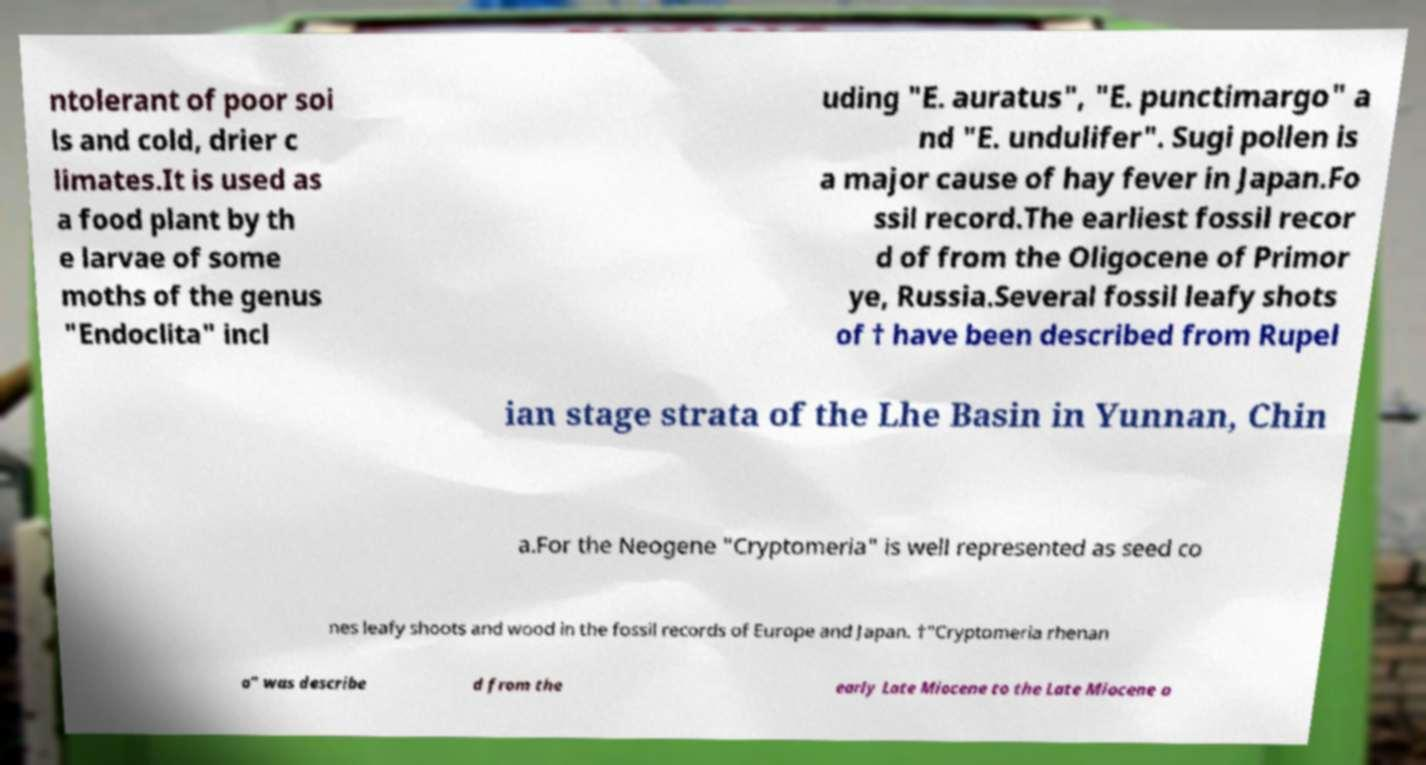For documentation purposes, I need the text within this image transcribed. Could you provide that? ntolerant of poor soi ls and cold, drier c limates.It is used as a food plant by th e larvae of some moths of the genus "Endoclita" incl uding "E. auratus", "E. punctimargo" a nd "E. undulifer". Sugi pollen is a major cause of hay fever in Japan.Fo ssil record.The earliest fossil recor d of from the Oligocene of Primor ye, Russia.Several fossil leafy shots of † have been described from Rupel ian stage strata of the Lhe Basin in Yunnan, Chin a.For the Neogene "Cryptomeria" is well represented as seed co nes leafy shoots and wood in the fossil records of Europe and Japan. †"Cryptomeria rhenan a" was describe d from the early Late Miocene to the Late Miocene o 